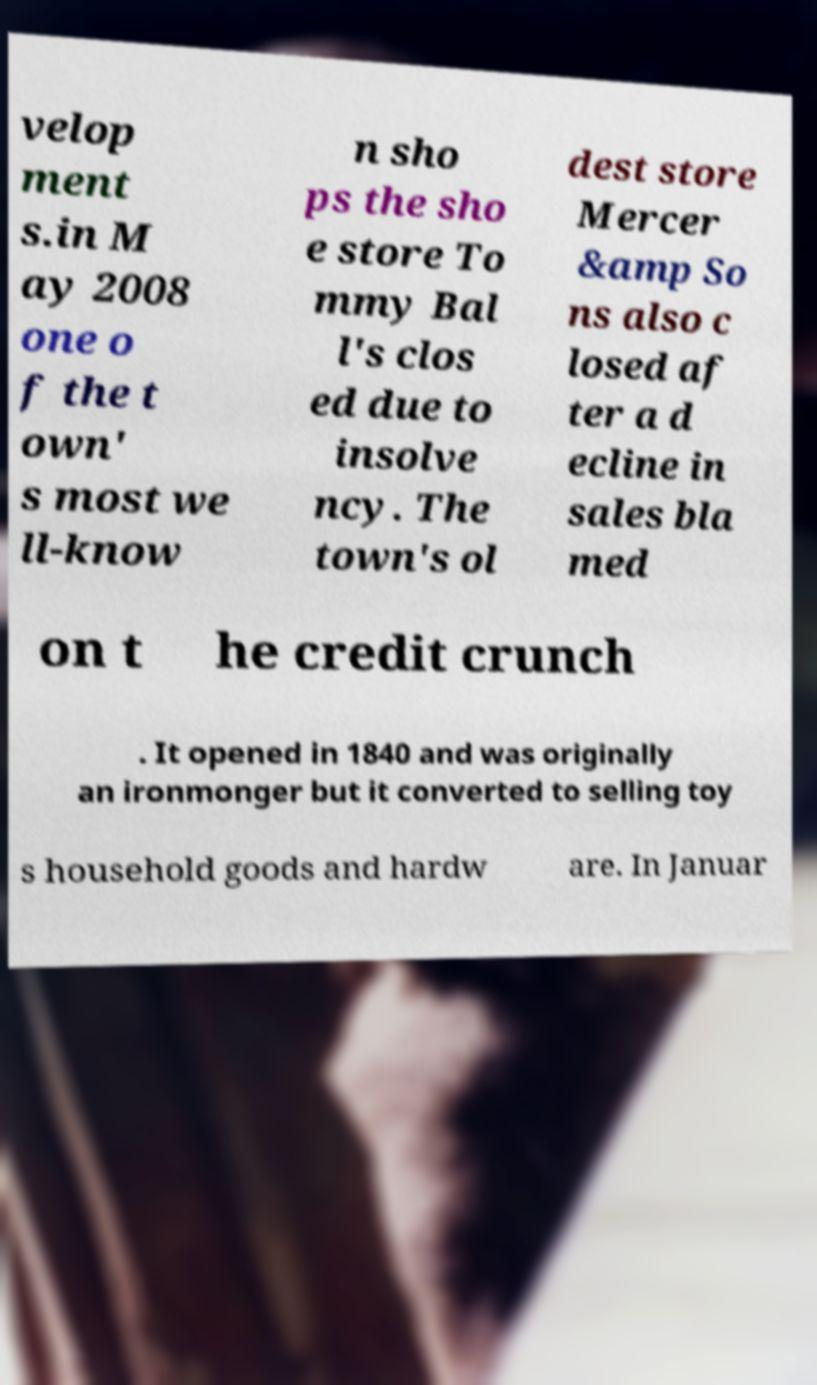There's text embedded in this image that I need extracted. Can you transcribe it verbatim? velop ment s.in M ay 2008 one o f the t own' s most we ll-know n sho ps the sho e store To mmy Bal l's clos ed due to insolve ncy. The town's ol dest store Mercer &amp So ns also c losed af ter a d ecline in sales bla med on t he credit crunch . It opened in 1840 and was originally an ironmonger but it converted to selling toy s household goods and hardw are. In Januar 